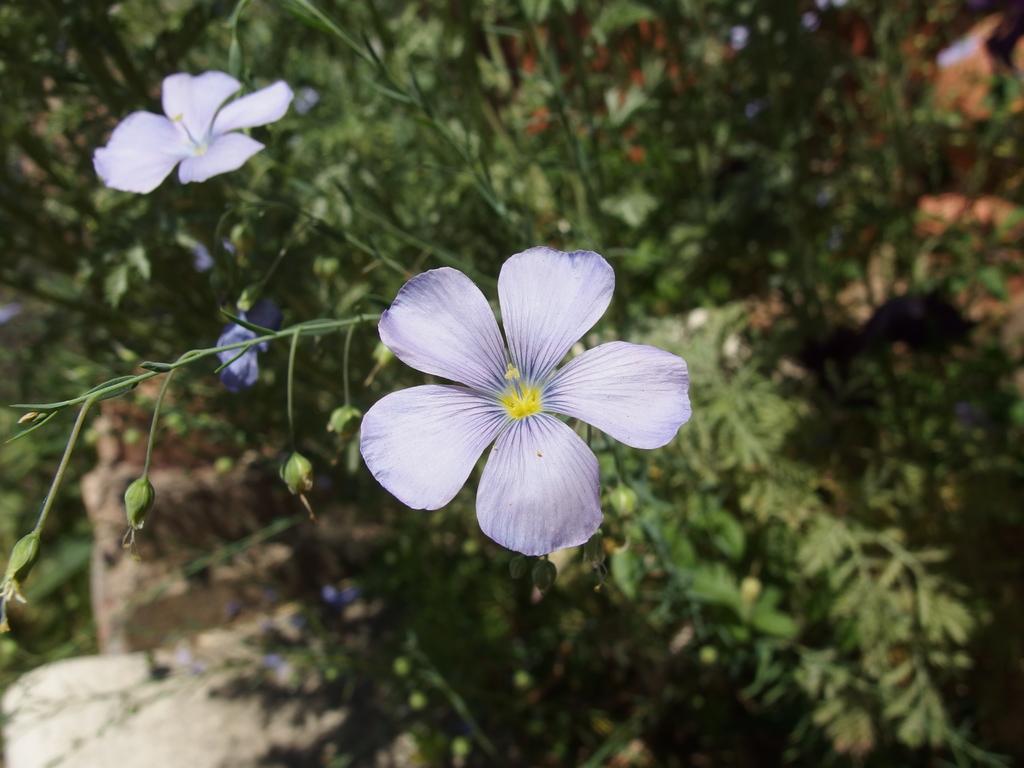Please provide a concise description of this image. Here I can see a few plants along with the flowers and birds. 